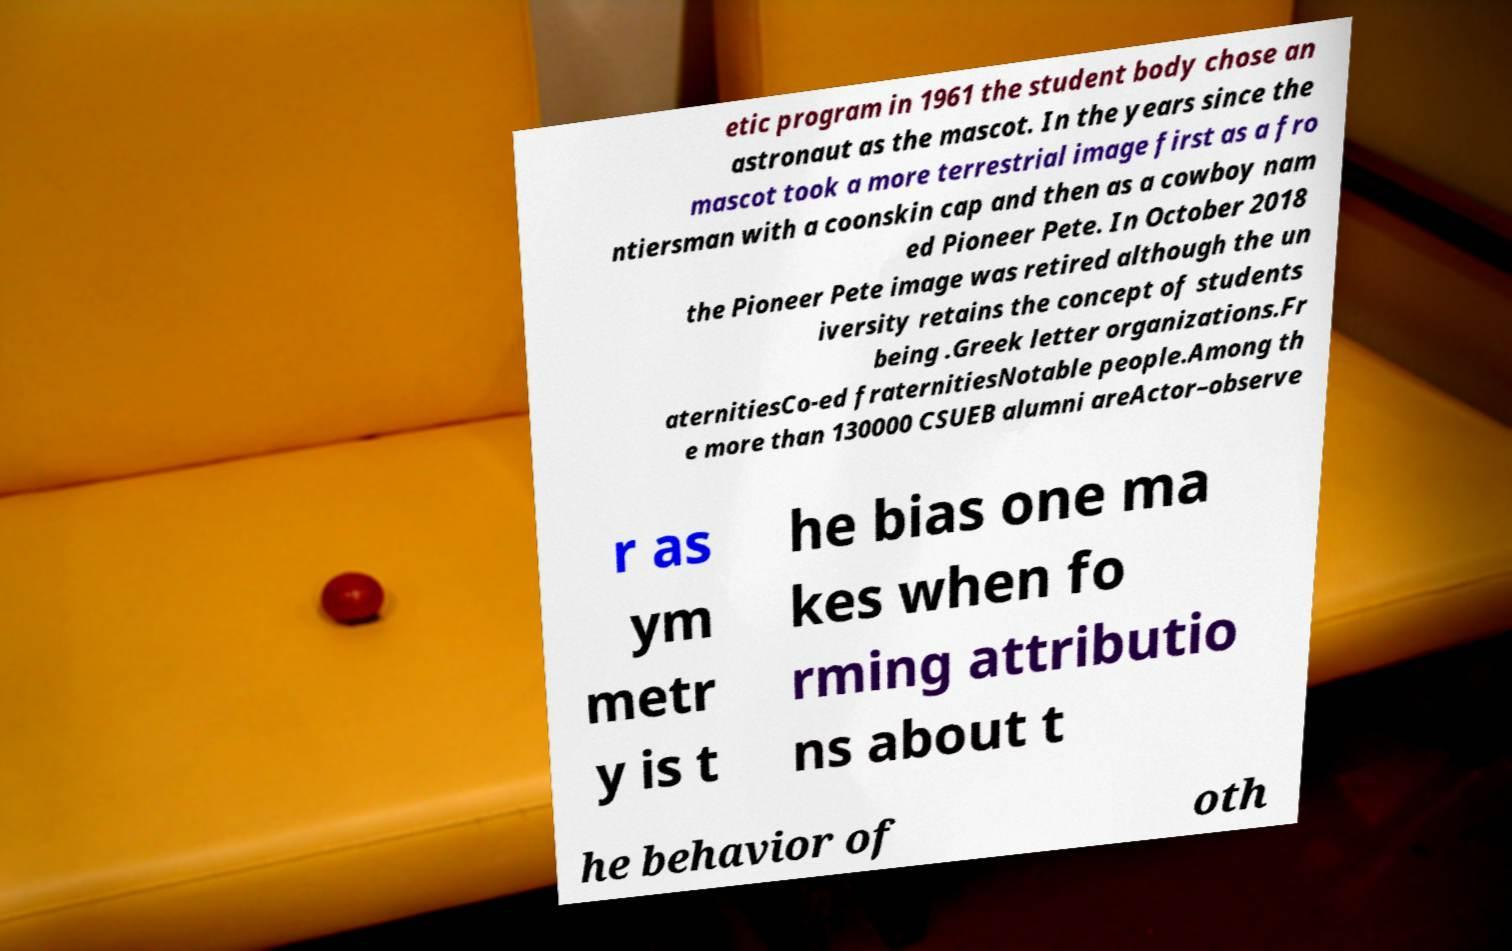What messages or text are displayed in this image? I need them in a readable, typed format. etic program in 1961 the student body chose an astronaut as the mascot. In the years since the mascot took a more terrestrial image first as a fro ntiersman with a coonskin cap and then as a cowboy nam ed Pioneer Pete. In October 2018 the Pioneer Pete image was retired although the un iversity retains the concept of students being .Greek letter organizations.Fr aternitiesCo-ed fraternitiesNotable people.Among th e more than 130000 CSUEB alumni areActor–observe r as ym metr y is t he bias one ma kes when fo rming attributio ns about t he behavior of oth 